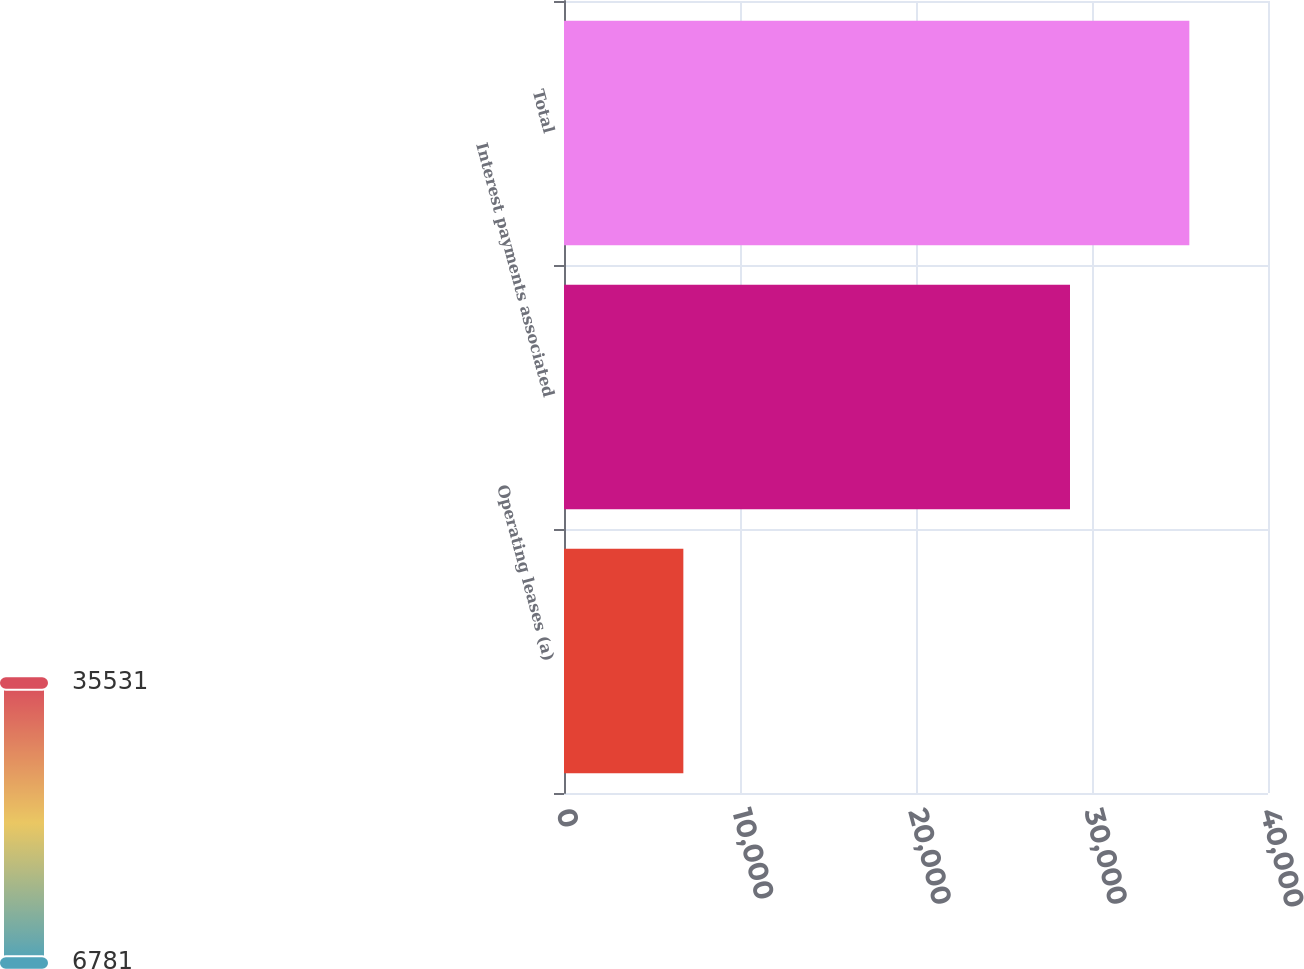<chart> <loc_0><loc_0><loc_500><loc_500><bar_chart><fcel>Operating leases (a)<fcel>Interest payments associated<fcel>Total<nl><fcel>6781<fcel>28750<fcel>35531<nl></chart> 